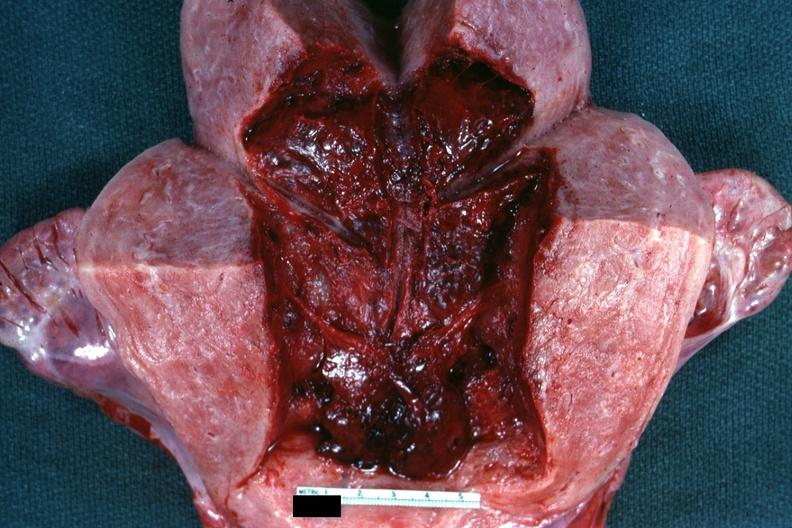what is present?
Answer the question using a single word or phrase. Uterus 